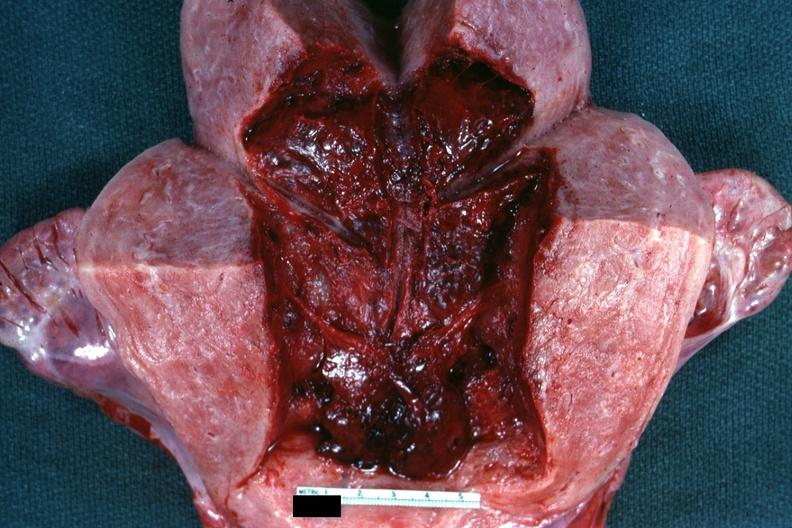what is present?
Answer the question using a single word or phrase. Uterus 